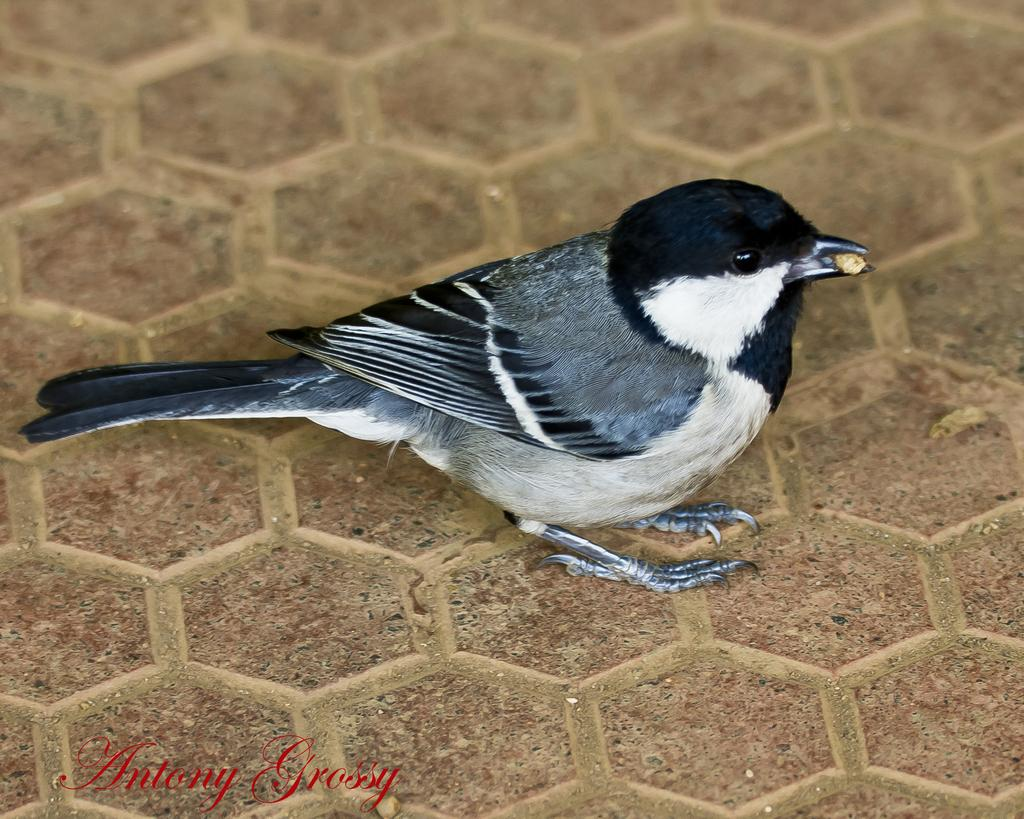What is the main subject in the center of the image? There is a bird in the center of the image. What is located at the bottom of the image? There is a floor at the bottom of the image. What can be found at the bottom of the image besides the floor? There is some text at the bottom of the image. What type of guitar is the bird playing in the image? There is no guitar present in the image; it features a bird in the center. What feeling does the bird convey in the image? The image does not convey a specific feeling, as it only shows a bird in the center. 